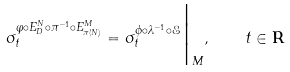Convert formula to latex. <formula><loc_0><loc_0><loc_500><loc_500>\sigma _ { t } ^ { \varphi \circ E _ { D } ^ { N } \circ \pi ^ { - 1 } \circ E _ { \pi ( N ) } ^ { M } } = \sigma _ { t } ^ { \phi \circ \lambda ^ { - 1 } \circ { \mathcal { E } } } \Big | _ { M } , \quad t \in { \mathbf R }</formula> 